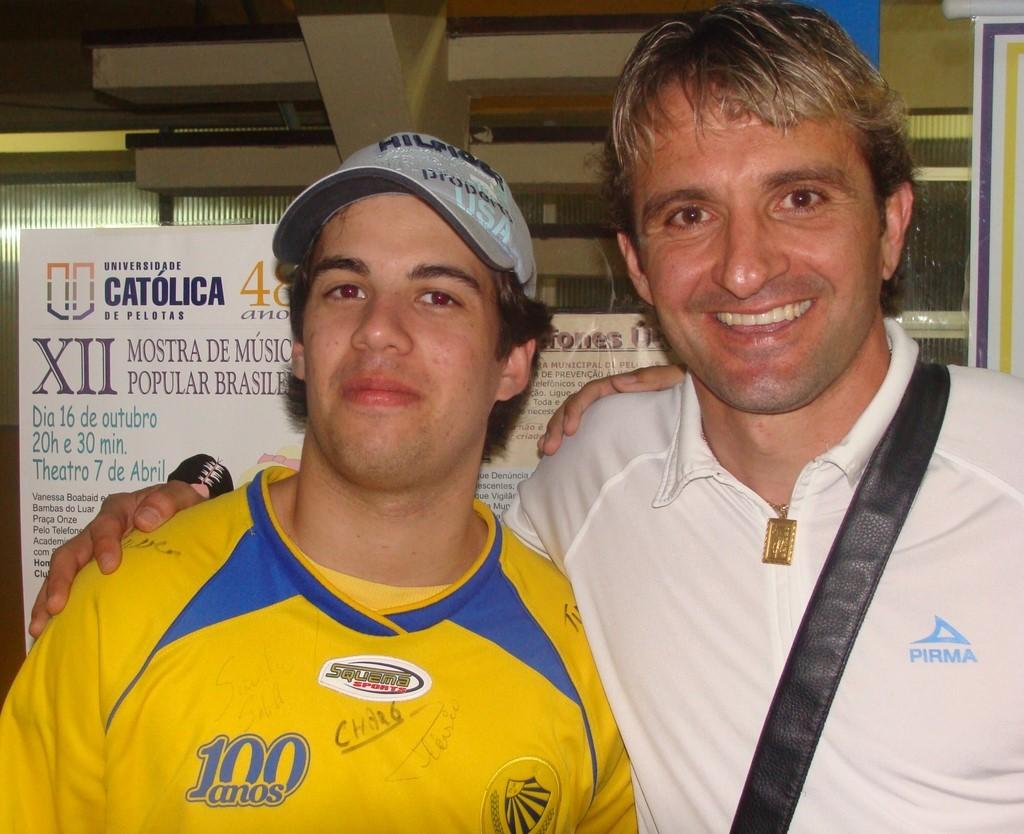<image>
Summarize the visual content of the image. Two guys posing for a photo in front of a Universidade Catholica poster. 